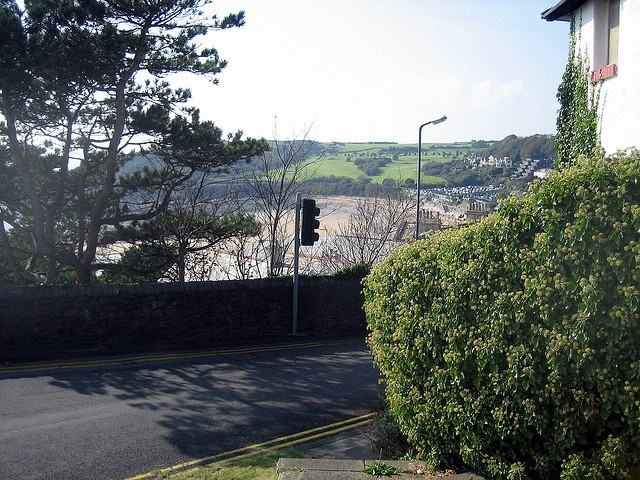Describe the objects in this image and their specific colors. I can see a traffic light in blue, black, gray, and darkgray tones in this image. 